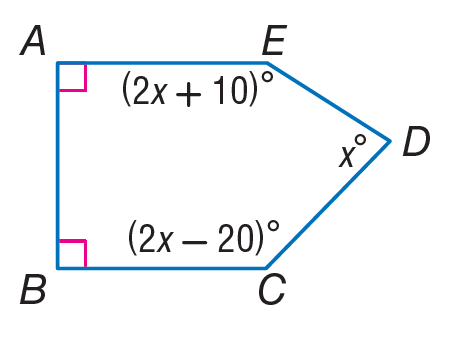Answer the mathemtical geometry problem and directly provide the correct option letter.
Question: Find m \angle E.
Choices: A: 38 B: 76 C: 79 D: 158 D 